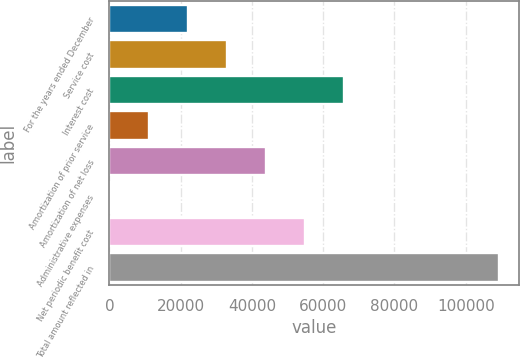Convert chart. <chart><loc_0><loc_0><loc_500><loc_500><bar_chart><fcel>For the years ended December<fcel>Service cost<fcel>Interest cost<fcel>Amortization of prior service<fcel>Amortization of net loss<fcel>Administrative expenses<fcel>Net periodic benefit cost<fcel>Total amount reflected in<nl><fcel>22130.2<fcel>33034.8<fcel>65748.6<fcel>11225.6<fcel>43939.4<fcel>321<fcel>54844<fcel>109367<nl></chart> 